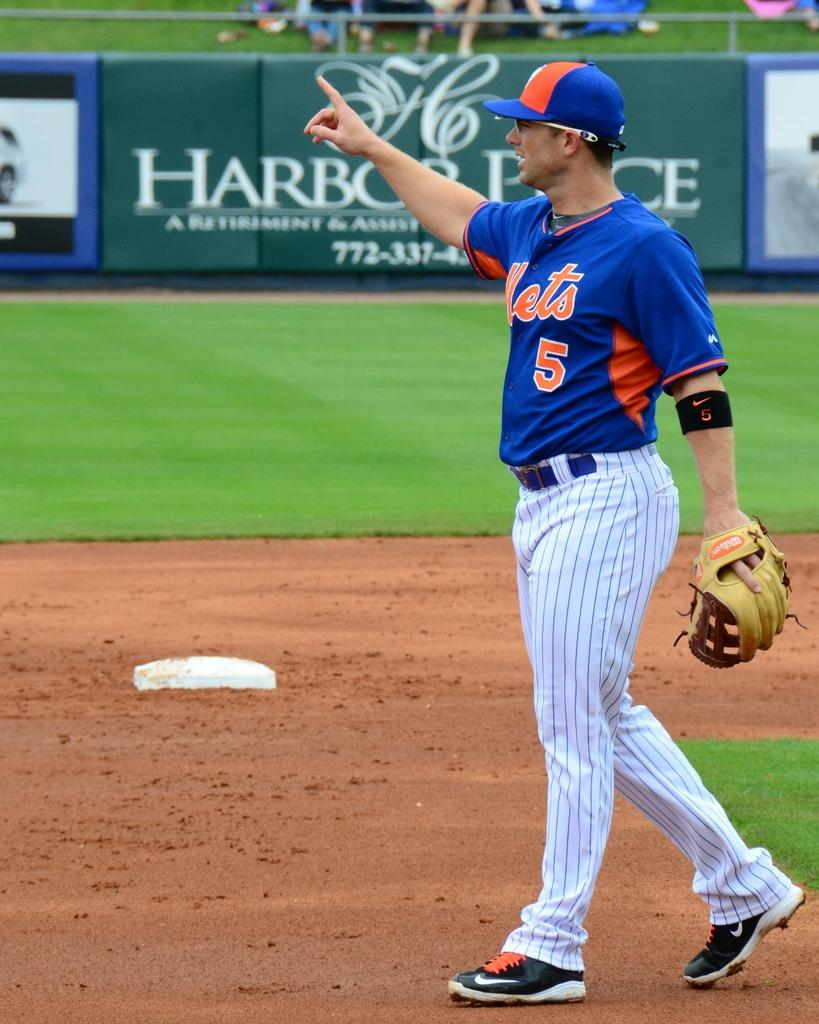<image>
Share a concise interpretation of the image provided. A baseball player wearing a Mets uniform with the number 5 on it. 